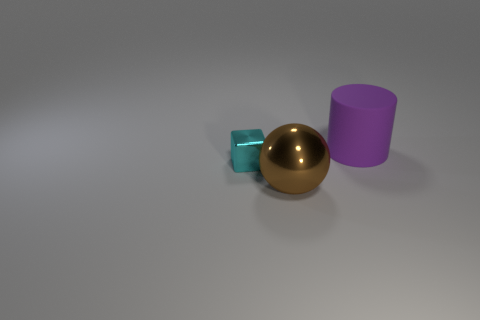Subtract all blocks. How many objects are left? 2 Add 2 purple things. How many objects exist? 5 Add 2 shiny things. How many shiny things are left? 4 Add 3 tiny gray matte spheres. How many tiny gray matte spheres exist? 3 Subtract 0 gray spheres. How many objects are left? 3 Subtract all large metal balls. Subtract all big brown balls. How many objects are left? 1 